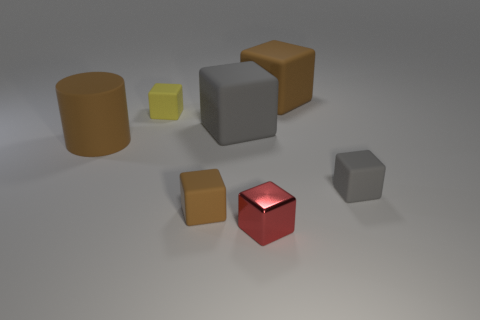Add 2 gray shiny spheres. How many objects exist? 9 Subtract all yellow blocks. How many blocks are left? 5 Subtract all brown rubber blocks. How many blocks are left? 4 Subtract all cubes. How many objects are left? 1 Subtract 1 cylinders. How many cylinders are left? 0 Add 5 red cylinders. How many red cylinders exist? 5 Subtract 0 green cylinders. How many objects are left? 7 Subtract all green cylinders. Subtract all gray cubes. How many cylinders are left? 1 Subtract all cyan blocks. How many gray cylinders are left? 0 Subtract all large brown matte blocks. Subtract all yellow cubes. How many objects are left? 5 